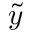<formula> <loc_0><loc_0><loc_500><loc_500>\tilde { y }</formula> 